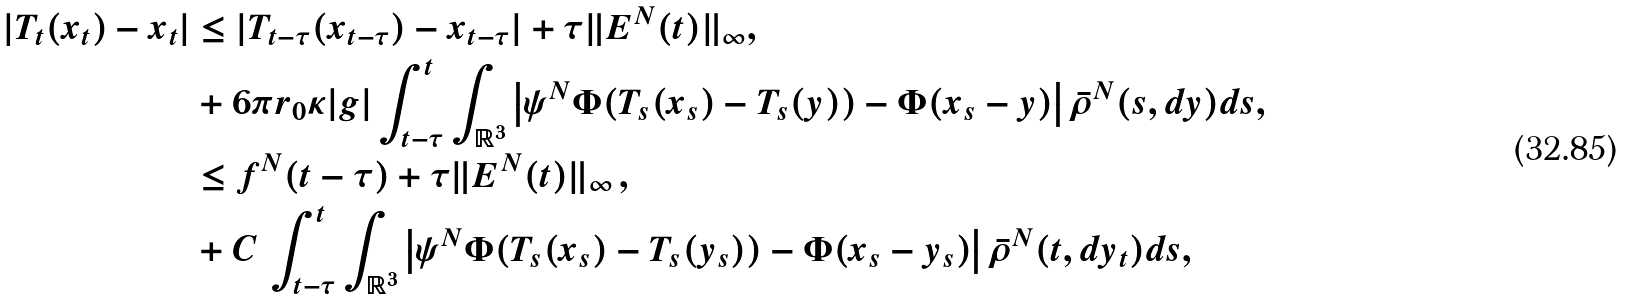Convert formula to latex. <formula><loc_0><loc_0><loc_500><loc_500>| T _ { t } ( x _ { t } ) - x _ { t } | & \leq | T _ { t - \tau } ( x _ { t - \tau } ) - x _ { t - \tau } | + \tau \| E ^ { N } ( t ) \| _ { \infty } , \\ & + 6 \pi r _ { 0 } \kappa | g | \int _ { t - \tau } ^ { t } \int _ { \mathbb { R } ^ { 3 } } \left | \psi ^ { N } \Phi ( T _ { s } ( x _ { s } ) - T _ { s } ( y ) ) - \Phi ( x _ { s } - y ) \right | \bar { \rho } ^ { N } ( s , d y ) d s , \\ & \leq f ^ { N } ( t - \tau ) + \tau \| E ^ { N } ( t ) \| _ { \infty } \, , \\ & + C \, \int _ { t - \tau } ^ { t } \int _ { \mathbb { R } ^ { 3 } } \left | \psi ^ { N } \Phi ( T _ { s } ( x _ { s } ) - T _ { s } ( y _ { s } ) ) - \Phi ( x _ { s } - y _ { s } ) \right | \bar { \rho } ^ { N } ( t , d y _ { t } ) d s ,</formula> 